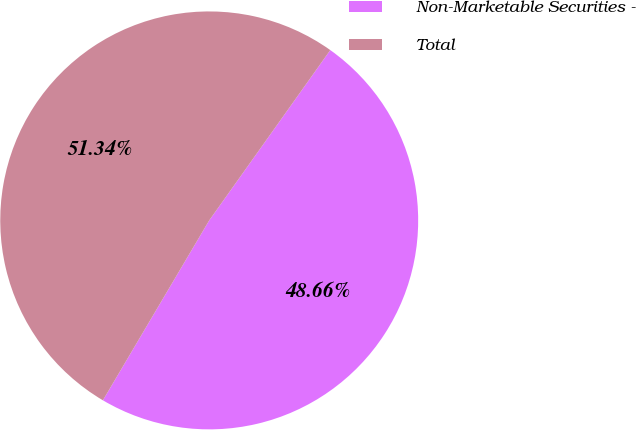<chart> <loc_0><loc_0><loc_500><loc_500><pie_chart><fcel>Non-Marketable Securities -<fcel>Total<nl><fcel>48.66%<fcel>51.34%<nl></chart> 